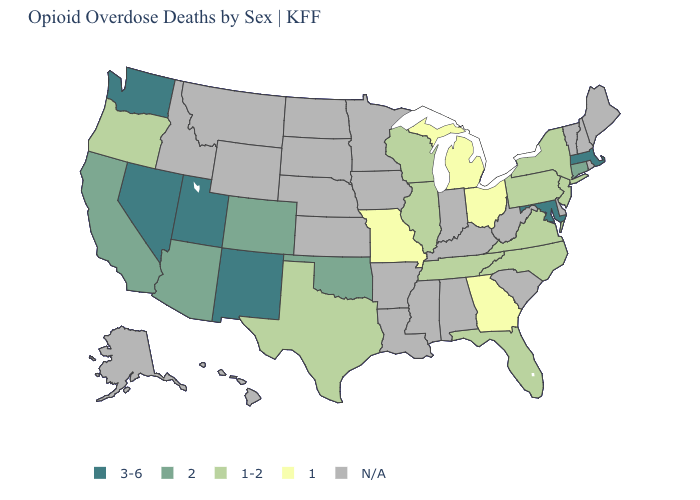What is the value of Wyoming?
Write a very short answer. N/A. Which states have the lowest value in the USA?
Be succinct. Georgia, Michigan, Missouri, Ohio. Name the states that have a value in the range 1-2?
Concise answer only. Florida, Illinois, New Jersey, New York, North Carolina, Oregon, Pennsylvania, Tennessee, Texas, Virginia, Wisconsin. Which states have the lowest value in the West?
Quick response, please. Oregon. Which states have the lowest value in the USA?
Keep it brief. Georgia, Michigan, Missouri, Ohio. Name the states that have a value in the range 1?
Short answer required. Georgia, Michigan, Missouri, Ohio. What is the highest value in the USA?
Keep it brief. 3-6. What is the highest value in the Northeast ?
Be succinct. 3-6. Name the states that have a value in the range 3-6?
Short answer required. Maryland, Massachusetts, Nevada, New Mexico, Utah, Washington. Is the legend a continuous bar?
Keep it brief. No. Is the legend a continuous bar?
Write a very short answer. No. Which states have the lowest value in the MidWest?
Keep it brief. Michigan, Missouri, Ohio. Does Washington have the lowest value in the West?
Quick response, please. No. Name the states that have a value in the range 2?
Short answer required. Arizona, California, Colorado, Connecticut, Oklahoma. 